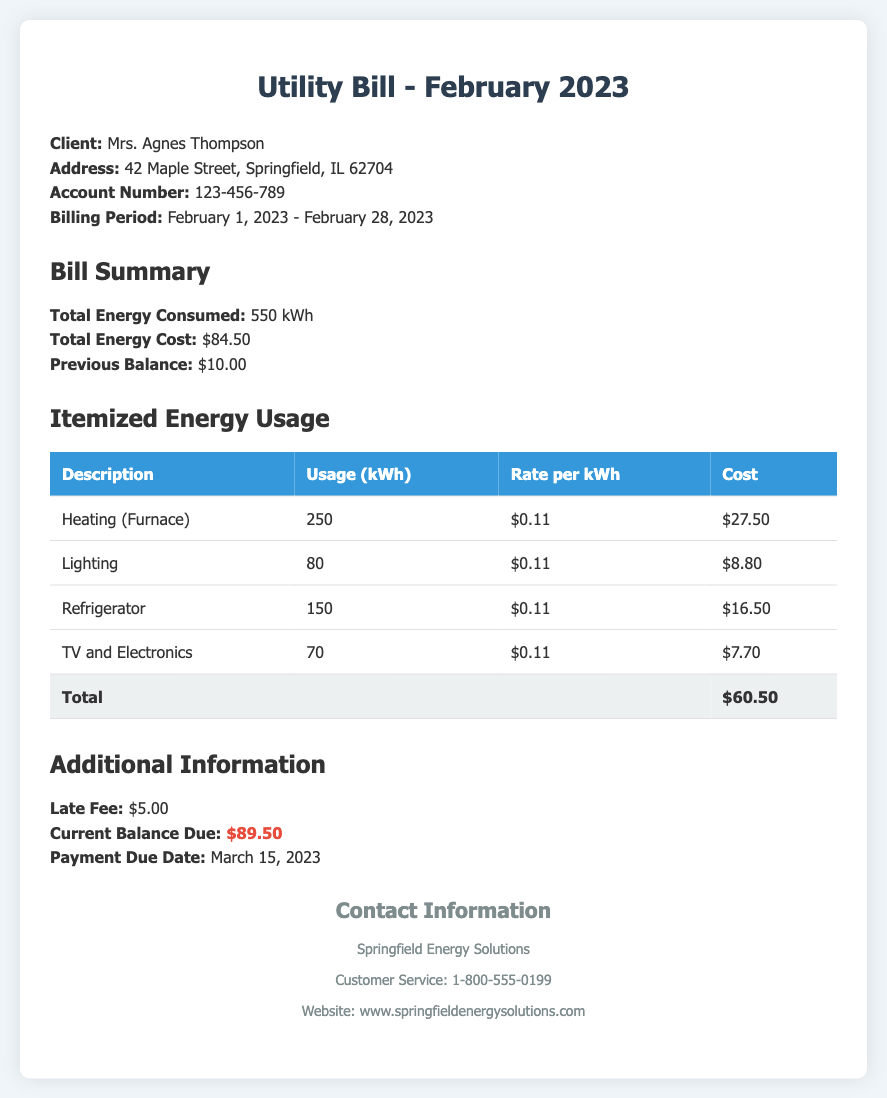What is the total energy consumed? The total energy consumed is stated in the bill summary section as 550 kWh.
Answer: 550 kWh What is the current balance due? The current balance due is highlighted in the additional information section as $89.50.
Answer: $89.50 What was the previous balance? The previous balance is mentioned in the bill summary section as $10.00.
Answer: $10.00 What is the due date for this payment? The payment due date is provided in the additional information section as March 15, 2023.
Answer: March 15, 2023 How much was the cost for the heating? The cost for heating (furnace) is detailed in the itemized energy usage as $27.50.
Answer: $27.50 What is the total energy cost? The total energy cost is stated in the bill summary as $84.50.
Answer: $84.50 What is the rate per kWh for lighting? The rate per kWh for lighting is mentioned in the itemized usage section as $0.11.
Answer: $0.11 What company issued this bill? The company that issued the bill is Springfield Energy Solutions, as shown in the contact information section.
Answer: Springfield Energy Solutions What additional fee is listed on the bill? An additional fee mentioned is a late fee of $5.00, found in the additional information section.
Answer: $5.00 